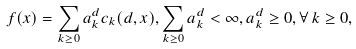<formula> <loc_0><loc_0><loc_500><loc_500>f ( x ) = \sum _ { k \geq 0 } a _ { k } ^ { d } c _ { k } ( d , x ) , \sum _ { k \geq 0 } a _ { k } ^ { d } < \infty , a _ { k } ^ { d } \geq 0 , \forall \, k \geq 0 ,</formula> 